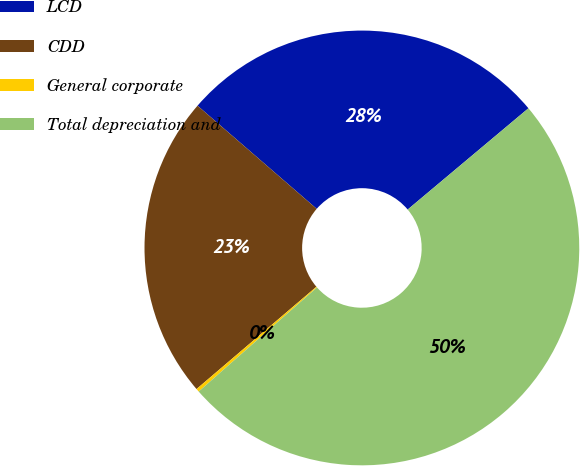Convert chart. <chart><loc_0><loc_0><loc_500><loc_500><pie_chart><fcel>LCD<fcel>CDD<fcel>General corporate<fcel>Total depreciation and<nl><fcel>27.54%<fcel>22.6%<fcel>0.24%<fcel>49.63%<nl></chart> 